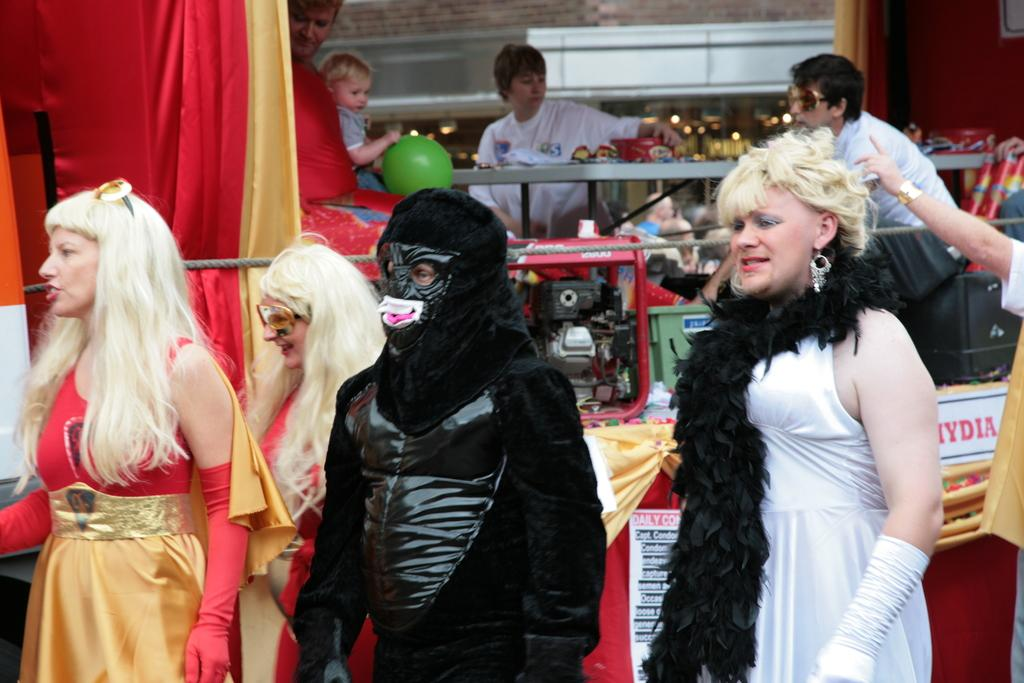How many people are in the image? There are four persons in the image. What are the persons wearing? The persons are wearing fancy dresses. What are the persons doing in the image? The persons are standing. What can be seen in the background of the image? There are clothes, a group of people sitting, a table, and some objects in the background. What type of unit can be seen in the image? There is no unit present in the image. Is there a drain visible in the image? There is no drain visible in the image. 